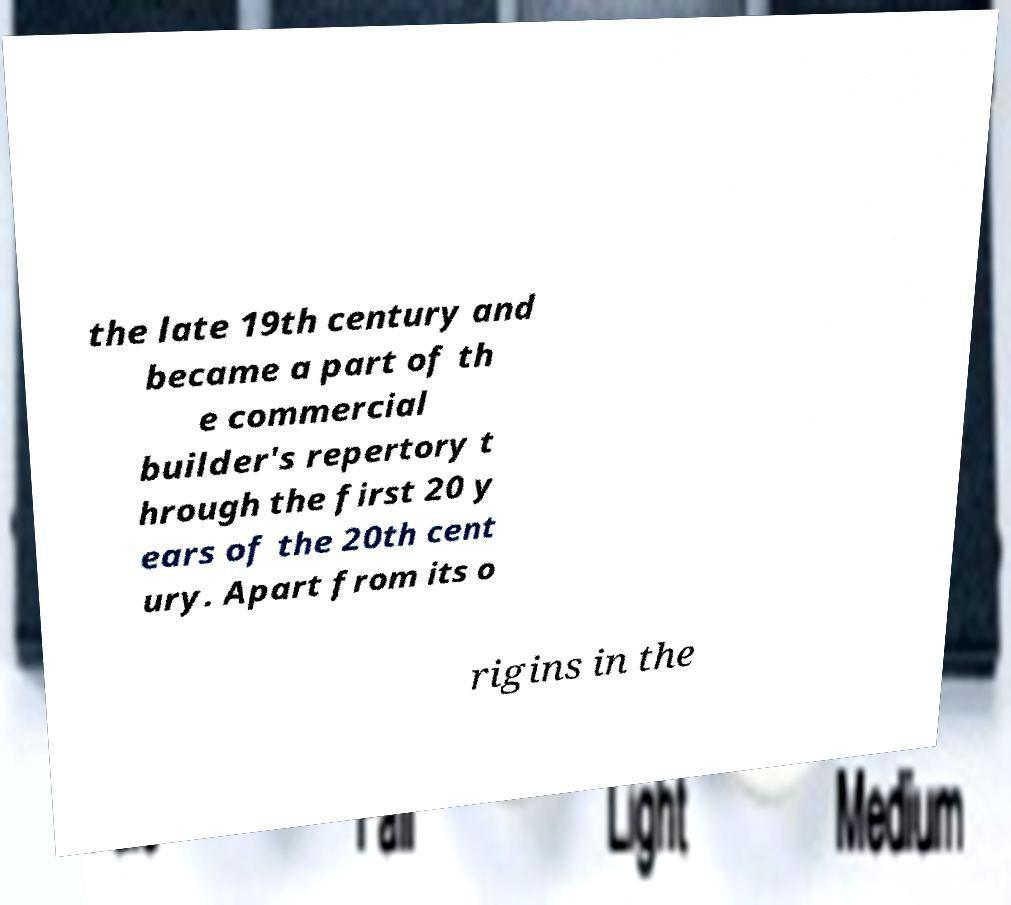Please read and relay the text visible in this image. What does it say? the late 19th century and became a part of th e commercial builder's repertory t hrough the first 20 y ears of the 20th cent ury. Apart from its o rigins in the 